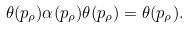Convert formula to latex. <formula><loc_0><loc_0><loc_500><loc_500>\theta ( p _ { \rho } ) \alpha ( p _ { \rho } ) \theta ( p _ { \rho } ) = \theta ( p _ { \rho } ) .</formula> 